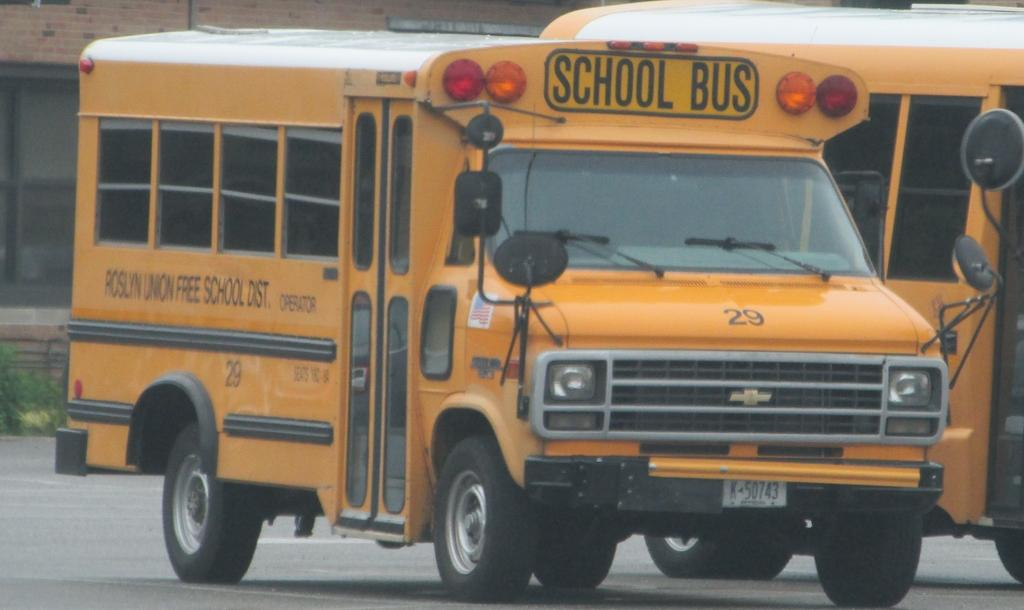<image>
Create a compact narrative representing the image presented. A school bus with "Roslyn Union Free School Dist." written on the side of it. 